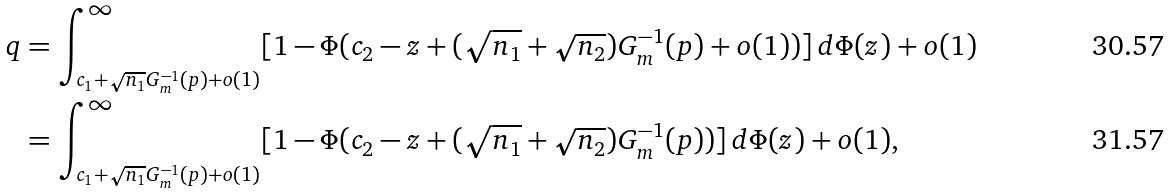Convert formula to latex. <formula><loc_0><loc_0><loc_500><loc_500>q & = \int _ { c _ { 1 } + \sqrt { n _ { 1 } } G _ { m } ^ { - 1 } ( p ) + o ( 1 ) } ^ { \infty } [ 1 - \Phi ( c _ { 2 } - z + ( \sqrt { n _ { 1 } } + \sqrt { n _ { 2 } } ) G _ { m } ^ { - 1 } ( p ) + o ( 1 ) ) ] \, d \Phi ( z ) + o ( 1 ) \\ & = \int _ { c _ { 1 } + \sqrt { n _ { 1 } } G _ { m } ^ { - 1 } ( p ) + o ( 1 ) } ^ { \infty } [ 1 - \Phi ( c _ { 2 } - z + ( \sqrt { n _ { 1 } } + \sqrt { n _ { 2 } } ) G _ { m } ^ { - 1 } ( p ) ) ] \, d \Phi ( z ) + o ( 1 ) ,</formula> 